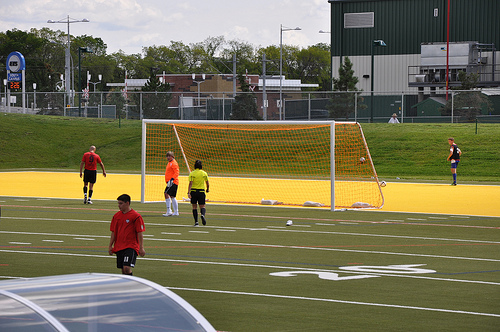<image>
Is the goalkeeper in front of the goal? Yes. The goalkeeper is positioned in front of the goal, appearing closer to the camera viewpoint. 